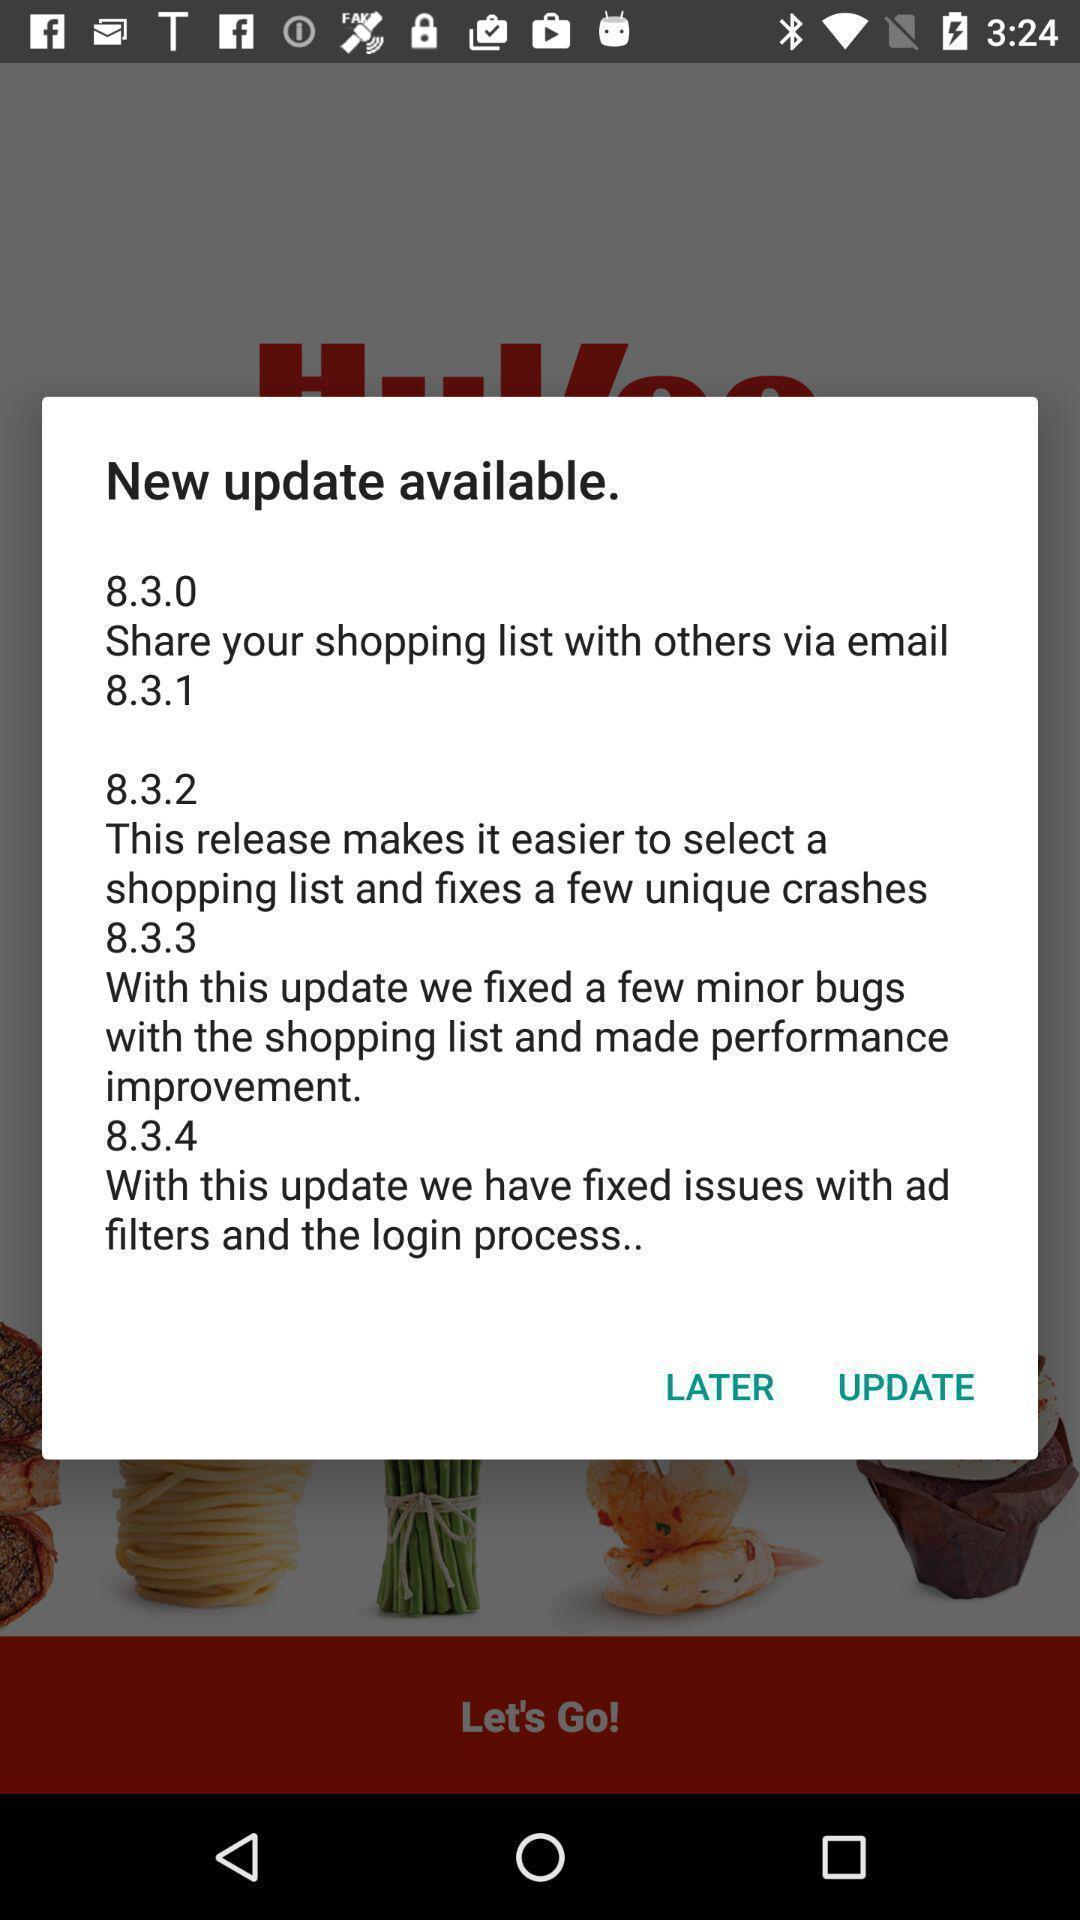Provide a textual representation of this image. Pop-up window showing message about app update. 